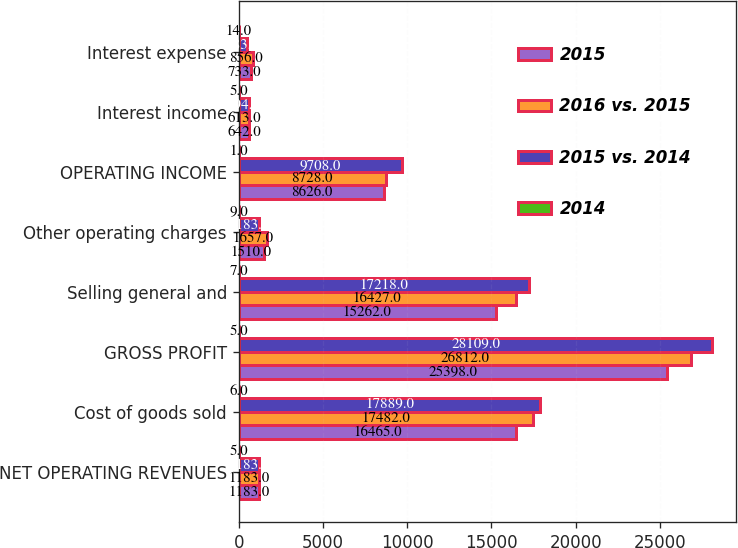Convert chart. <chart><loc_0><loc_0><loc_500><loc_500><stacked_bar_chart><ecel><fcel>NET OPERATING REVENUES<fcel>Cost of goods sold<fcel>GROSS PROFIT<fcel>Selling general and<fcel>Other operating charges<fcel>OPERATING INCOME<fcel>Interest income<fcel>Interest expense<nl><fcel>2015<fcel>1183<fcel>16465<fcel>25398<fcel>15262<fcel>1510<fcel>8626<fcel>642<fcel>733<nl><fcel>2016 vs. 2015<fcel>1183<fcel>17482<fcel>26812<fcel>16427<fcel>1657<fcel>8728<fcel>613<fcel>856<nl><fcel>2015 vs. 2014<fcel>1183<fcel>17889<fcel>28109<fcel>17218<fcel>1183<fcel>9708<fcel>594<fcel>483<nl><fcel>2014<fcel>5<fcel>6<fcel>5<fcel>7<fcel>9<fcel>1<fcel>5<fcel>14<nl></chart> 